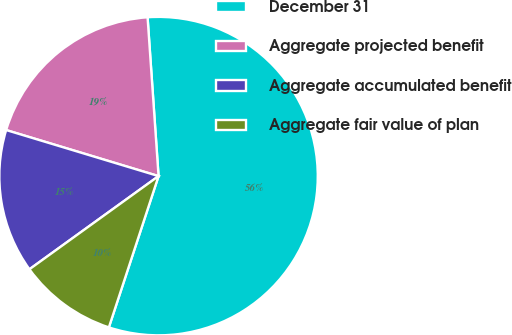<chart> <loc_0><loc_0><loc_500><loc_500><pie_chart><fcel>December 31<fcel>Aggregate projected benefit<fcel>Aggregate accumulated benefit<fcel>Aggregate fair value of plan<nl><fcel>56.15%<fcel>19.23%<fcel>14.62%<fcel>10.0%<nl></chart> 